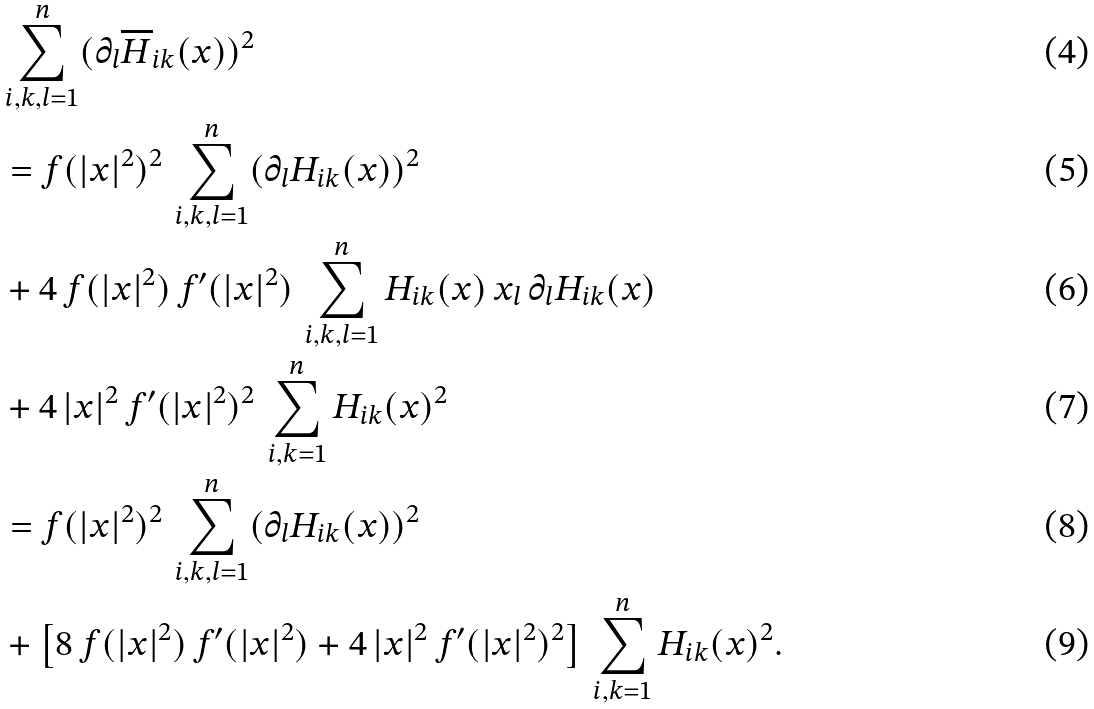Convert formula to latex. <formula><loc_0><loc_0><loc_500><loc_500>& \sum _ { i , k , l = 1 } ^ { n } ( \partial _ { l } \overline { H } _ { i k } ( x ) ) ^ { 2 } \\ & = f ( | x | ^ { 2 } ) ^ { 2 } \, \sum _ { i , k , l = 1 } ^ { n } ( \partial _ { l } H _ { i k } ( x ) ) ^ { 2 } \\ & + 4 \, f ( | x | ^ { 2 } ) \, f ^ { \prime } ( | x | ^ { 2 } ) \, \sum _ { i , k , l = 1 } ^ { n } H _ { i k } ( x ) \, x _ { l } \, \partial _ { l } H _ { i k } ( x ) \\ & + 4 \, | x | ^ { 2 } \, f ^ { \prime } ( | x | ^ { 2 } ) ^ { 2 } \, \sum _ { i , k = 1 } ^ { n } H _ { i k } ( x ) ^ { 2 } \\ & = f ( | x | ^ { 2 } ) ^ { 2 } \, \sum _ { i , k , l = 1 } ^ { n } ( \partial _ { l } H _ { i k } ( x ) ) ^ { 2 } \\ & + \left [ 8 \, f ( | x | ^ { 2 } ) \, f ^ { \prime } ( | x | ^ { 2 } ) + 4 \, | x | ^ { 2 } \, f ^ { \prime } ( | x | ^ { 2 } ) ^ { 2 } \right ] \, \sum _ { i , k = 1 } ^ { n } H _ { i k } ( x ) ^ { 2 } .</formula> 